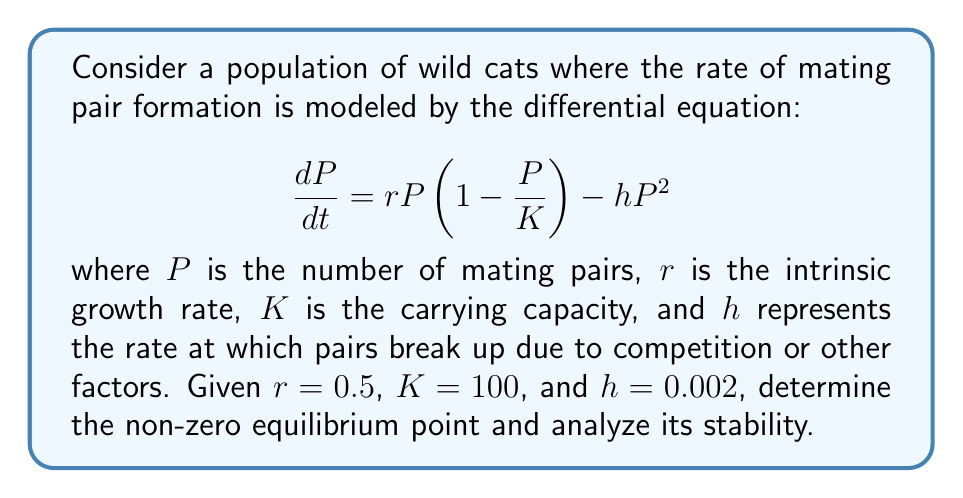Teach me how to tackle this problem. 1. To find the equilibrium points, set $\frac{dP}{dt} = 0$:

   $$ 0 = rP(1 - \frac{P}{K}) - hP^2 $$

2. Factor out $P$:

   $$ 0 = P(r(1 - \frac{P}{K}) - hP) $$

3. Solve for $P$:
   
   $P = 0$ (trivial solution)
   
   For the non-zero solution:
   
   $$ r(1 - \frac{P}{K}) - hP = 0 $$
   
   $$ r - \frac{rP}{K} - hP = 0 $$
   
   $$ r = P(\frac{r}{K} + h) $$
   
   $$ P = \frac{r}{\frac{r}{K} + h} $$

4. Substitute the given values:

   $$ P = \frac{0.5}{\frac{0.5}{100} + 0.002} = 71.43 $$

5. To analyze stability, find the derivative of $\frac{dP}{dt}$ with respect to $P$:

   $$ \frac{d}{dP}(\frac{dP}{dt}) = r(1 - \frac{2P}{K}) - 2hP $$

6. Evaluate this at the equilibrium point $P = 71.43$:

   $$ \frac{d}{dP}(\frac{dP}{dt})|_{P=71.43} = 0.5(1 - \frac{2(71.43)}{100}) - 2(0.002)(71.43) = -0.3572 $$

7. Since this value is negative, the equilibrium point is stable.
Answer: Stable equilibrium at $P \approx 71.43$ mating pairs. 